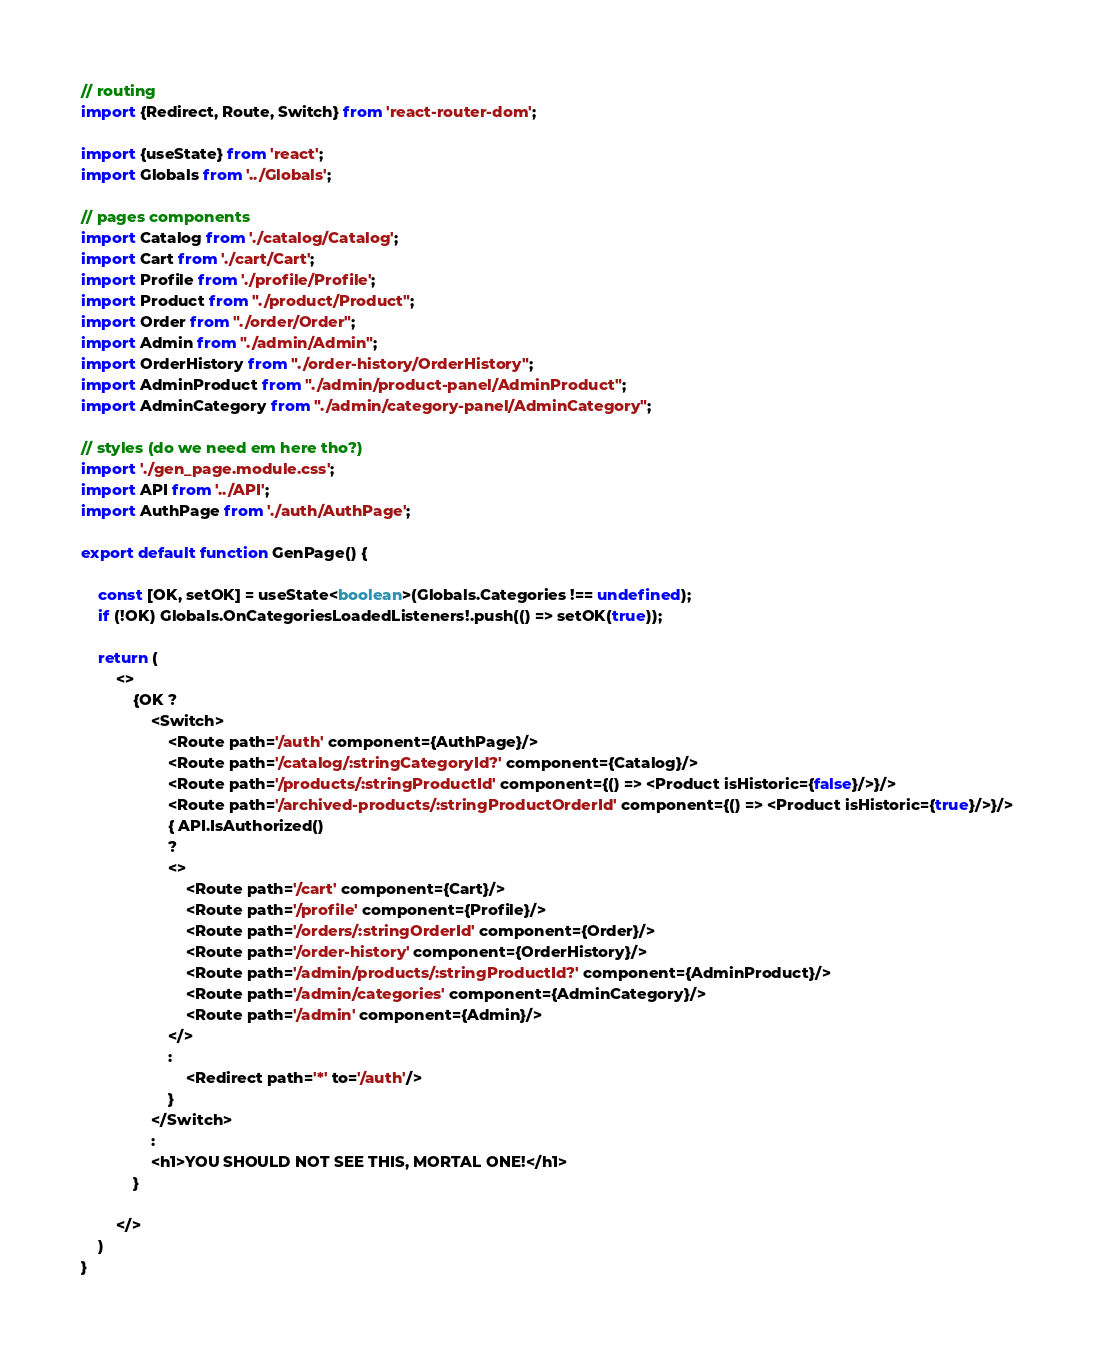Convert code to text. <code><loc_0><loc_0><loc_500><loc_500><_TypeScript_>// routing
import {Redirect, Route, Switch} from 'react-router-dom';

import {useState} from 'react';
import Globals from '../Globals';

// pages components
import Catalog from './catalog/Catalog';
import Cart from './cart/Cart';
import Profile from './profile/Profile';
import Product from "./product/Product";
import Order from "./order/Order";
import Admin from "./admin/Admin";
import OrderHistory from "./order-history/OrderHistory";
import AdminProduct from "./admin/product-panel/AdminProduct";
import AdminCategory from "./admin/category-panel/AdminCategory";

// styles (do we need em here tho?)
import './gen_page.module.css';
import API from '../API';
import AuthPage from './auth/AuthPage';

export default function GenPage() {

    const [OK, setOK] = useState<boolean>(Globals.Categories !== undefined);
    if (!OK) Globals.OnCategoriesLoadedListeners!.push(() => setOK(true));

    return (
        <>
            {OK ?
                <Switch>
                    <Route path='/auth' component={AuthPage}/>
                    <Route path='/catalog/:stringCategoryId?' component={Catalog}/>
                    <Route path='/products/:stringProductId' component={() => <Product isHistoric={false}/>}/>
                    <Route path='/archived-products/:stringProductOrderId' component={() => <Product isHistoric={true}/>}/>
                    { API.IsAuthorized()
                    ?
                    <>
                        <Route path='/cart' component={Cart}/>
                        <Route path='/profile' component={Profile}/>
                        <Route path='/orders/:stringOrderId' component={Order}/>
                        <Route path='/order-history' component={OrderHistory}/>
                        <Route path='/admin/products/:stringProductId?' component={AdminProduct}/>
                        <Route path='/admin/categories' component={AdminCategory}/>
                        <Route path='/admin' component={Admin}/>
                    </>
                    :
                        <Redirect path='*' to='/auth'/>
                    }
                </Switch>
                :
                <h1>YOU SHOULD NOT SEE THIS, MORTAL ONE!</h1>
            }

        </>
    )
}
</code> 